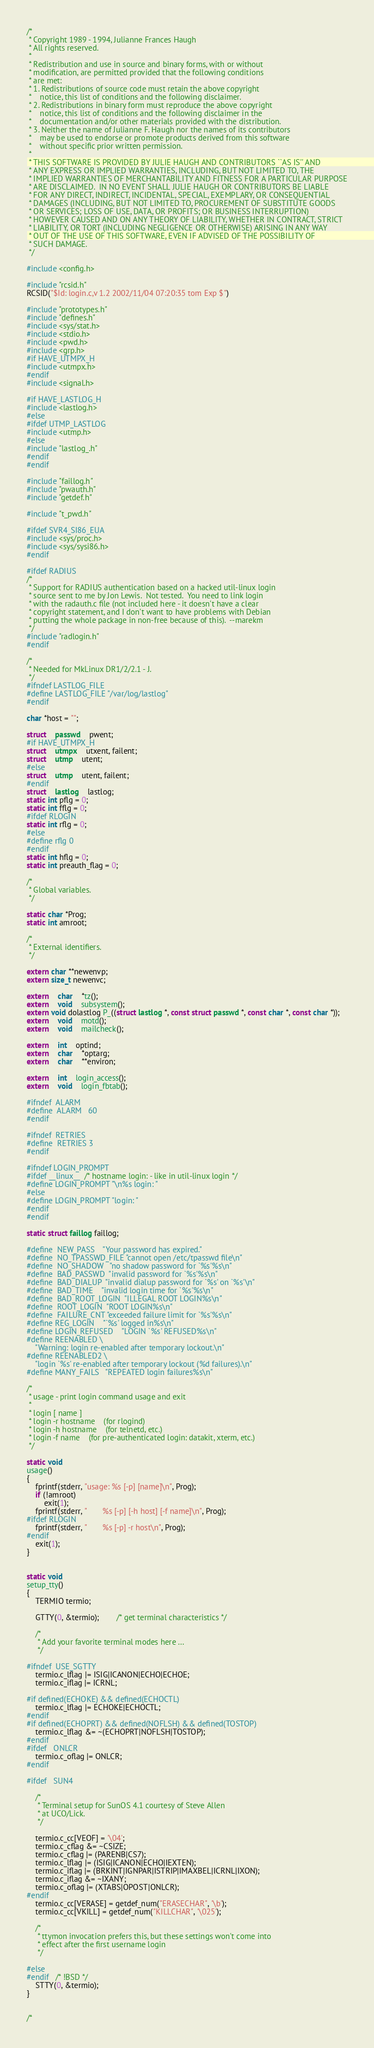Convert code to text. <code><loc_0><loc_0><loc_500><loc_500><_C_>/*
 * Copyright 1989 - 1994, Julianne Frances Haugh
 * All rights reserved.
 *
 * Redistribution and use in source and binary forms, with or without
 * modification, are permitted provided that the following conditions
 * are met:
 * 1. Redistributions of source code must retain the above copyright
 *    notice, this list of conditions and the following disclaimer.
 * 2. Redistributions in binary form must reproduce the above copyright
 *    notice, this list of conditions and the following disclaimer in the
 *    documentation and/or other materials provided with the distribution.
 * 3. Neither the name of Julianne F. Haugh nor the names of its contributors
 *    may be used to endorse or promote products derived from this software
 *    without specific prior written permission.
 *
 * THIS SOFTWARE IS PROVIDED BY JULIE HAUGH AND CONTRIBUTORS ``AS IS'' AND
 * ANY EXPRESS OR IMPLIED WARRANTIES, INCLUDING, BUT NOT LIMITED TO, THE
 * IMPLIED WARRANTIES OF MERCHANTABILITY AND FITNESS FOR A PARTICULAR PURPOSE
 * ARE DISCLAIMED.  IN NO EVENT SHALL JULIE HAUGH OR CONTRIBUTORS BE LIABLE
 * FOR ANY DIRECT, INDIRECT, INCIDENTAL, SPECIAL, EXEMPLARY, OR CONSEQUENTIAL
 * DAMAGES (INCLUDING, BUT NOT LIMITED TO, PROCUREMENT OF SUBSTITUTE GOODS
 * OR SERVICES; LOSS OF USE, DATA, OR PROFITS; OR BUSINESS INTERRUPTION)
 * HOWEVER CAUSED AND ON ANY THEORY OF LIABILITY, WHETHER IN CONTRACT, STRICT
 * LIABILITY, OR TORT (INCLUDING NEGLIGENCE OR OTHERWISE) ARISING IN ANY WAY
 * OUT OF THE USE OF THIS SOFTWARE, EVEN IF ADVISED OF THE POSSIBILITY OF
 * SUCH DAMAGE.
 */

#include <config.h>

#include "rcsid.h"
RCSID("$Id: login.c,v 1.2 2002/11/04 07:20:35 tom Exp $")

#include "prototypes.h"
#include "defines.h"
#include <sys/stat.h>
#include <stdio.h>
#include <pwd.h>
#include <grp.h>
#if HAVE_UTMPX_H
#include <utmpx.h>
#endif
#include <signal.h>

#if HAVE_LASTLOG_H
#include <lastlog.h>
#else
#ifdef UTMP_LASTLOG
#include <utmp.h>
#else
#include "lastlog_.h"
#endif
#endif

#include "faillog.h"
#include "pwauth.h"
#include "getdef.h"

#include "t_pwd.h"

#ifdef SVR4_SI86_EUA
#include <sys/proc.h>
#include <sys/sysi86.h>
#endif

#ifdef RADIUS
/*
 * Support for RADIUS authentication based on a hacked util-linux login
 * source sent to me by Jon Lewis.  Not tested.  You need to link login
 * with the radauth.c file (not included here - it doesn't have a clear
 * copyright statement, and I don't want to have problems with Debian
 * putting the whole package in non-free because of this).  --marekm
 */
#include "radlogin.h"
#endif

/*
 * Needed for MkLinux DR1/2/2.1 - J.
 */
#ifndef LASTLOG_FILE
#define LASTLOG_FILE "/var/log/lastlog"
#endif

char *host = "";

struct	passwd	pwent;
#if HAVE_UTMPX_H
struct	utmpx	utxent, failent;
struct	utmp	utent;
#else
struct	utmp	utent, failent;
#endif
struct	lastlog	lastlog;
static int pflg = 0;
static int fflg = 0;
#ifdef RLOGIN
static int rflg = 0;
#else
#define rflg 0
#endif
static int hflg = 0;
static int preauth_flag = 0;

/*
 * Global variables.
 */

static char *Prog;
static int amroot;

/*
 * External identifiers.
 */

extern char **newenvp;
extern size_t newenvc;

extern	char	*tz();
extern	void	subsystem();
extern void dolastlog P_((struct lastlog *, const struct passwd *, const char *, const char *));
extern	void	motd();
extern	void	mailcheck();

extern	int	optind;
extern	char	*optarg;
extern	char	**environ;

extern	int	login_access();
extern	void	login_fbtab();

#ifndef	ALARM
#define	ALARM	60
#endif

#ifndef	RETRIES
#define	RETRIES	3
#endif

#ifndef LOGIN_PROMPT
#ifdef __linux__  /* hostname login: - like in util-linux login */
#define LOGIN_PROMPT "\n%s login: "
#else
#define LOGIN_PROMPT "login: "
#endif
#endif

static struct faillog faillog;

#define	NEW_PASS	"Your password has expired."
#define	NO_TPASSWD_FILE "cannot open /etc/tpasswd file\n"
#define	NO_SHADOW	"no shadow password for `%s'%s\n"
#define	BAD_PASSWD	"invalid password for `%s'%s\n"
#define	BAD_DIALUP	"invalid dialup password for `%s' on `%s'\n"
#define	BAD_TIME	"invalid login time for `%s'%s\n"
#define	BAD_ROOT_LOGIN	"ILLEGAL ROOT LOGIN%s\n"
#define	ROOT_LOGIN	"ROOT LOGIN%s\n"
#define	FAILURE_CNT	"exceeded failure limit for `%s'%s\n"
#define REG_LOGIN	"`%s' logged in%s\n"
#define LOGIN_REFUSED	"LOGIN `%s' REFUSED%s\n"
#define REENABLED \
	"Warning: login re-enabled after temporary lockout.\n"
#define REENABLED2 \
	"login `%s' re-enabled after temporary lockout (%d failures).\n"
#define MANY_FAILS	"REPEATED login failures%s\n"

/*
 * usage - print login command usage and exit
 *
 * login [ name ]
 * login -r hostname	(for rlogind)
 * login -h hostname	(for telnetd, etc.)
 * login -f name	(for pre-authenticated login: datakit, xterm, etc.)
 */

static void
usage()
{
	fprintf(stderr, "usage: %s [-p] [name]\n", Prog);
	if (!amroot)
		exit(1);
	fprintf(stderr, "       %s [-p] [-h host] [-f name]\n", Prog);
#ifdef RLOGIN
	fprintf(stderr, "       %s [-p] -r host\n", Prog);
#endif
	exit(1);
}


static void
setup_tty()
{
	TERMIO termio;

	GTTY(0, &termio);		/* get terminal characteristics */

	/*
	 * Add your favorite terminal modes here ...
	 */

#ifndef	USE_SGTTY
	termio.c_lflag |= ISIG|ICANON|ECHO|ECHOE;
	termio.c_iflag |= ICRNL;

#if defined(ECHOKE) && defined(ECHOCTL)
	termio.c_lflag |= ECHOKE|ECHOCTL;
#endif
#if defined(ECHOPRT) && defined(NOFLSH) && defined(TOSTOP)
	termio.c_lflag &= ~(ECHOPRT|NOFLSH|TOSTOP);
#endif
#ifdef	ONLCR
	termio.c_oflag |= ONLCR;
#endif

#ifdef	SUN4

	/*
	 * Terminal setup for SunOS 4.1 courtesy of Steve Allen
	 * at UCO/Lick.
	 */

	termio.c_cc[VEOF] = '\04';
	termio.c_cflag &= ~CSIZE;
	termio.c_cflag |= (PARENB|CS7);
	termio.c_lflag |= (ISIG|ICANON|ECHO|IEXTEN);
	termio.c_iflag |= (BRKINT|IGNPAR|ISTRIP|IMAXBEL|ICRNL|IXON);
	termio.c_iflag &= ~IXANY;
	termio.c_oflag |= (XTABS|OPOST|ONLCR);
#endif
	termio.c_cc[VERASE] = getdef_num("ERASECHAR", '\b');
	termio.c_cc[VKILL] = getdef_num("KILLCHAR", '\025');

	/*
	 * ttymon invocation prefers this, but these settings won't come into
	 * effect after the first username login 
	 */

#else
#endif	/* !BSD */
	STTY(0, &termio);
}


/*</code> 